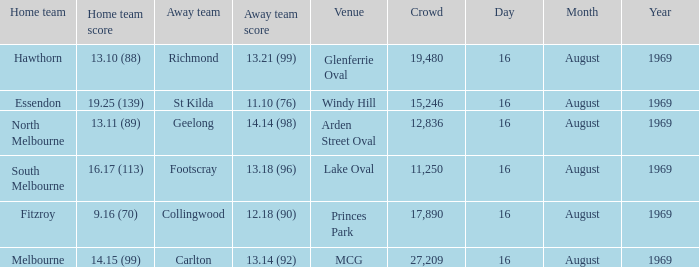What was the away team's score at Princes Park? 12.18 (90). 